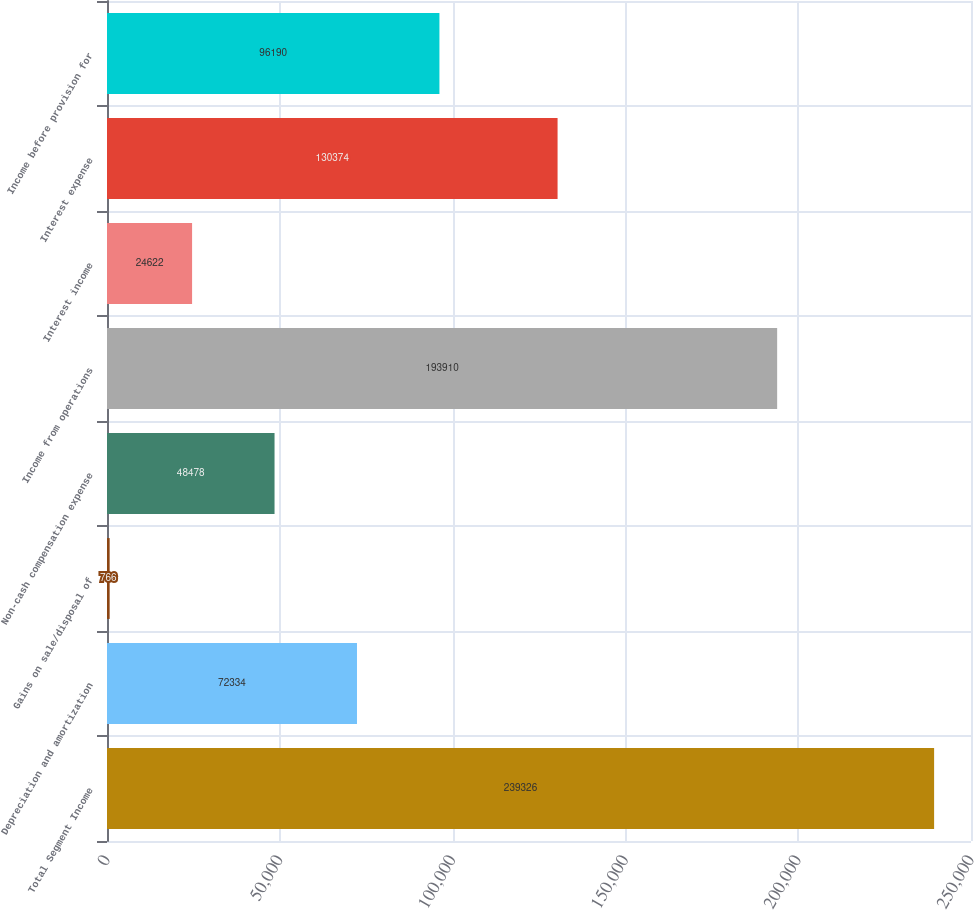Convert chart to OTSL. <chart><loc_0><loc_0><loc_500><loc_500><bar_chart><fcel>Total Segment Income<fcel>Depreciation and amortization<fcel>Gains on sale/disposal of<fcel>Non-cash compensation expense<fcel>Income from operations<fcel>Interest income<fcel>Interest expense<fcel>Income before provision for<nl><fcel>239326<fcel>72334<fcel>766<fcel>48478<fcel>193910<fcel>24622<fcel>130374<fcel>96190<nl></chart> 